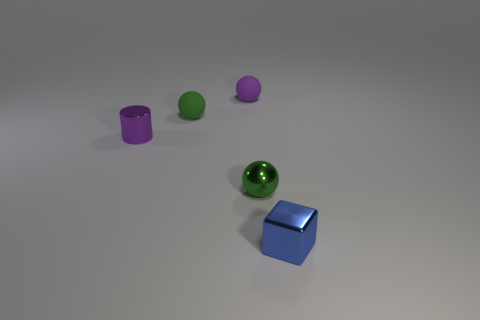What is the material of the other green ball that is the same size as the metallic ball?
Give a very brief answer. Rubber. Is the number of small blue metal blocks greater than the number of green objects?
Your answer should be very brief. No. What is the color of the shiny object that is on the left side of the green metallic ball?
Provide a succinct answer. Purple. What number of green metallic things have the same size as the purple cylinder?
Your answer should be compact. 1. What material is the tiny purple object that is the same shape as the small green rubber object?
Make the answer very short. Rubber. Do the small green metal object and the tiny green matte thing have the same shape?
Your response must be concise. Yes. There is a tiny cylinder; how many tiny things are right of it?
Ensure brevity in your answer.  4. The shiny thing in front of the tiny sphere that is in front of the metallic cylinder is what shape?
Your answer should be very brief. Cube. What shape is the green object that is made of the same material as the purple ball?
Your answer should be very brief. Sphere. The small blue object that is on the right side of the cylinder has what shape?
Provide a succinct answer. Cube. 